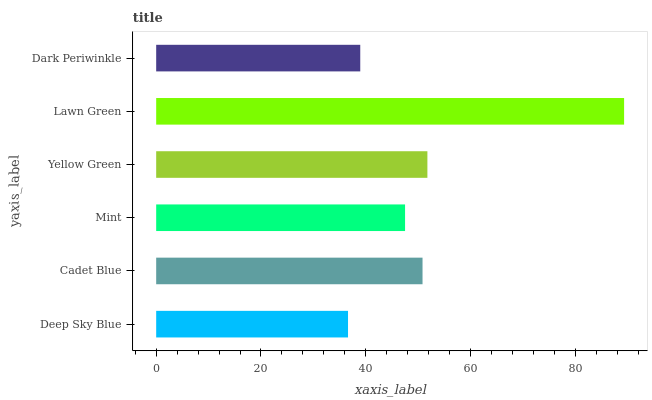Is Deep Sky Blue the minimum?
Answer yes or no. Yes. Is Lawn Green the maximum?
Answer yes or no. Yes. Is Cadet Blue the minimum?
Answer yes or no. No. Is Cadet Blue the maximum?
Answer yes or no. No. Is Cadet Blue greater than Deep Sky Blue?
Answer yes or no. Yes. Is Deep Sky Blue less than Cadet Blue?
Answer yes or no. Yes. Is Deep Sky Blue greater than Cadet Blue?
Answer yes or no. No. Is Cadet Blue less than Deep Sky Blue?
Answer yes or no. No. Is Cadet Blue the high median?
Answer yes or no. Yes. Is Mint the low median?
Answer yes or no. Yes. Is Yellow Green the high median?
Answer yes or no. No. Is Dark Periwinkle the low median?
Answer yes or no. No. 